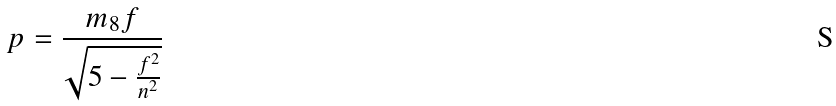<formula> <loc_0><loc_0><loc_500><loc_500>p = \frac { m _ { 8 } f } { \sqrt { 5 - \frac { f ^ { 2 } } { n ^ { 2 } } } }</formula> 